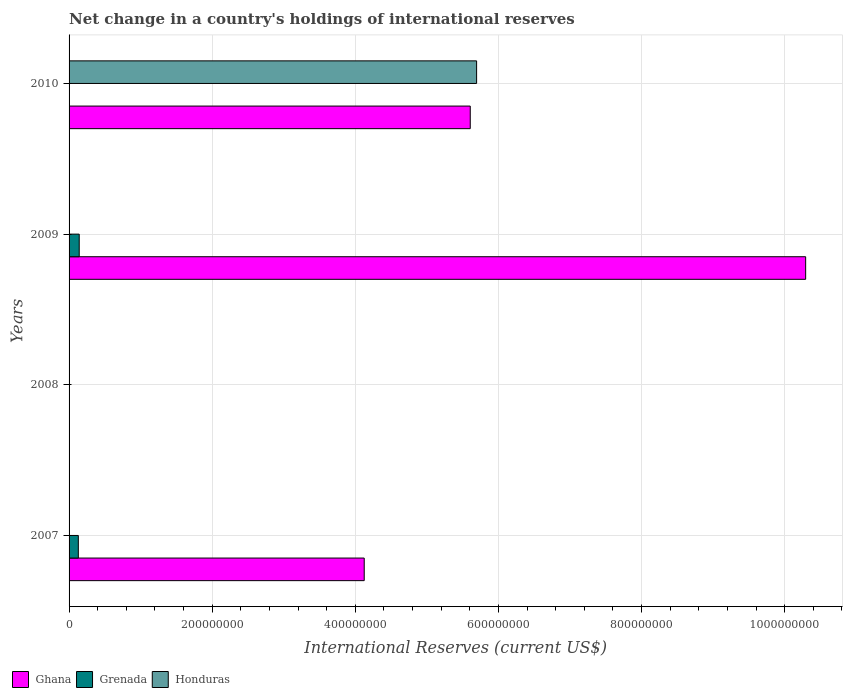Are the number of bars on each tick of the Y-axis equal?
Offer a very short reply. No. How many bars are there on the 1st tick from the top?
Your response must be concise. 2. How many bars are there on the 3rd tick from the bottom?
Your answer should be very brief. 2. In how many cases, is the number of bars for a given year not equal to the number of legend labels?
Keep it short and to the point. 4. Across all years, what is the maximum international reserves in Grenada?
Provide a short and direct response. 1.42e+07. Across all years, what is the minimum international reserves in Grenada?
Your response must be concise. 0. In which year was the international reserves in Grenada maximum?
Make the answer very short. 2009. What is the total international reserves in Ghana in the graph?
Provide a succinct answer. 2.00e+09. What is the difference between the international reserves in Ghana in 2007 and that in 2009?
Your answer should be very brief. -6.17e+08. What is the difference between the international reserves in Honduras in 2009 and the international reserves in Grenada in 2008?
Offer a very short reply. 0. What is the average international reserves in Grenada per year?
Make the answer very short. 6.77e+06. In the year 2009, what is the difference between the international reserves in Grenada and international reserves in Ghana?
Ensure brevity in your answer.  -1.02e+09. In how many years, is the international reserves in Honduras greater than 520000000 US$?
Ensure brevity in your answer.  1. What is the ratio of the international reserves in Ghana in 2007 to that in 2010?
Your answer should be compact. 0.74. Is the international reserves in Ghana in 2009 less than that in 2010?
Provide a short and direct response. No. Is the difference between the international reserves in Grenada in 2007 and 2009 greater than the difference between the international reserves in Ghana in 2007 and 2009?
Make the answer very short. Yes. What is the difference between the highest and the second highest international reserves in Ghana?
Provide a short and direct response. 4.69e+08. What is the difference between the highest and the lowest international reserves in Honduras?
Offer a terse response. 5.70e+08. In how many years, is the international reserves in Grenada greater than the average international reserves in Grenada taken over all years?
Your response must be concise. 2. How many bars are there?
Ensure brevity in your answer.  6. What is the difference between two consecutive major ticks on the X-axis?
Provide a short and direct response. 2.00e+08. Are the values on the major ticks of X-axis written in scientific E-notation?
Your response must be concise. No. Does the graph contain any zero values?
Your answer should be compact. Yes. Does the graph contain grids?
Your answer should be very brief. Yes. What is the title of the graph?
Make the answer very short. Net change in a country's holdings of international reserves. Does "Micronesia" appear as one of the legend labels in the graph?
Provide a short and direct response. No. What is the label or title of the X-axis?
Keep it short and to the point. International Reserves (current US$). What is the label or title of the Y-axis?
Your answer should be compact. Years. What is the International Reserves (current US$) of Ghana in 2007?
Give a very brief answer. 4.12e+08. What is the International Reserves (current US$) of Grenada in 2007?
Give a very brief answer. 1.29e+07. What is the International Reserves (current US$) in Grenada in 2008?
Provide a short and direct response. 0. What is the International Reserves (current US$) in Ghana in 2009?
Your answer should be compact. 1.03e+09. What is the International Reserves (current US$) of Grenada in 2009?
Give a very brief answer. 1.42e+07. What is the International Reserves (current US$) of Honduras in 2009?
Make the answer very short. 0. What is the International Reserves (current US$) in Ghana in 2010?
Your answer should be compact. 5.61e+08. What is the International Reserves (current US$) of Honduras in 2010?
Provide a succinct answer. 5.70e+08. Across all years, what is the maximum International Reserves (current US$) of Ghana?
Provide a succinct answer. 1.03e+09. Across all years, what is the maximum International Reserves (current US$) of Grenada?
Your answer should be compact. 1.42e+07. Across all years, what is the maximum International Reserves (current US$) of Honduras?
Your answer should be compact. 5.70e+08. Across all years, what is the minimum International Reserves (current US$) of Grenada?
Keep it short and to the point. 0. What is the total International Reserves (current US$) in Ghana in the graph?
Provide a succinct answer. 2.00e+09. What is the total International Reserves (current US$) in Grenada in the graph?
Your response must be concise. 2.71e+07. What is the total International Reserves (current US$) in Honduras in the graph?
Offer a very short reply. 5.70e+08. What is the difference between the International Reserves (current US$) in Ghana in 2007 and that in 2009?
Give a very brief answer. -6.17e+08. What is the difference between the International Reserves (current US$) in Grenada in 2007 and that in 2009?
Your response must be concise. -1.25e+06. What is the difference between the International Reserves (current US$) in Ghana in 2007 and that in 2010?
Offer a very short reply. -1.48e+08. What is the difference between the International Reserves (current US$) in Ghana in 2009 and that in 2010?
Your answer should be compact. 4.69e+08. What is the difference between the International Reserves (current US$) of Ghana in 2007 and the International Reserves (current US$) of Grenada in 2009?
Ensure brevity in your answer.  3.98e+08. What is the difference between the International Reserves (current US$) in Ghana in 2007 and the International Reserves (current US$) in Honduras in 2010?
Your answer should be compact. -1.57e+08. What is the difference between the International Reserves (current US$) of Grenada in 2007 and the International Reserves (current US$) of Honduras in 2010?
Offer a terse response. -5.57e+08. What is the difference between the International Reserves (current US$) in Ghana in 2009 and the International Reserves (current US$) in Honduras in 2010?
Ensure brevity in your answer.  4.60e+08. What is the difference between the International Reserves (current US$) of Grenada in 2009 and the International Reserves (current US$) of Honduras in 2010?
Offer a very short reply. -5.55e+08. What is the average International Reserves (current US$) in Ghana per year?
Offer a very short reply. 5.01e+08. What is the average International Reserves (current US$) in Grenada per year?
Keep it short and to the point. 6.77e+06. What is the average International Reserves (current US$) of Honduras per year?
Give a very brief answer. 1.42e+08. In the year 2007, what is the difference between the International Reserves (current US$) in Ghana and International Reserves (current US$) in Grenada?
Your answer should be very brief. 4.00e+08. In the year 2009, what is the difference between the International Reserves (current US$) in Ghana and International Reserves (current US$) in Grenada?
Offer a very short reply. 1.02e+09. In the year 2010, what is the difference between the International Reserves (current US$) of Ghana and International Reserves (current US$) of Honduras?
Your answer should be very brief. -8.89e+06. What is the ratio of the International Reserves (current US$) of Ghana in 2007 to that in 2009?
Your answer should be compact. 0.4. What is the ratio of the International Reserves (current US$) in Grenada in 2007 to that in 2009?
Offer a terse response. 0.91. What is the ratio of the International Reserves (current US$) in Ghana in 2007 to that in 2010?
Your answer should be compact. 0.74. What is the ratio of the International Reserves (current US$) of Ghana in 2009 to that in 2010?
Provide a succinct answer. 1.84. What is the difference between the highest and the second highest International Reserves (current US$) of Ghana?
Make the answer very short. 4.69e+08. What is the difference between the highest and the lowest International Reserves (current US$) in Ghana?
Provide a succinct answer. 1.03e+09. What is the difference between the highest and the lowest International Reserves (current US$) of Grenada?
Give a very brief answer. 1.42e+07. What is the difference between the highest and the lowest International Reserves (current US$) in Honduras?
Your answer should be very brief. 5.70e+08. 